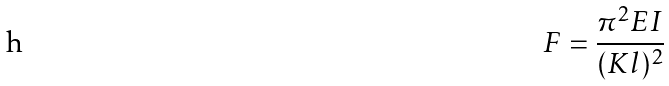<formula> <loc_0><loc_0><loc_500><loc_500>F = \frac { \pi ^ { 2 } E I } { ( K l ) ^ { 2 } }</formula> 